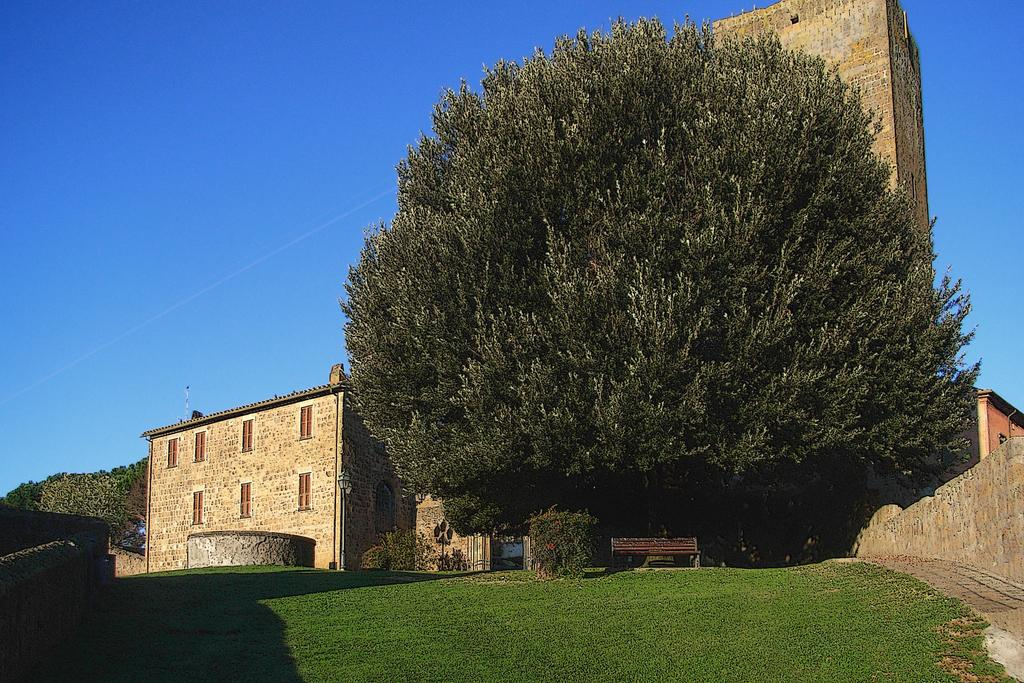What type of structure is visible in the image? There is a building in the image. What is located in front of the building? There is a huge tree in front of the building. What is under the tree? There is a bench below the tree. What type of vegetation is present in front of the building? There is a lot of grass in front of the building. How many rings are hanging from the tree in the image? There are no rings hanging from the tree in the image. 